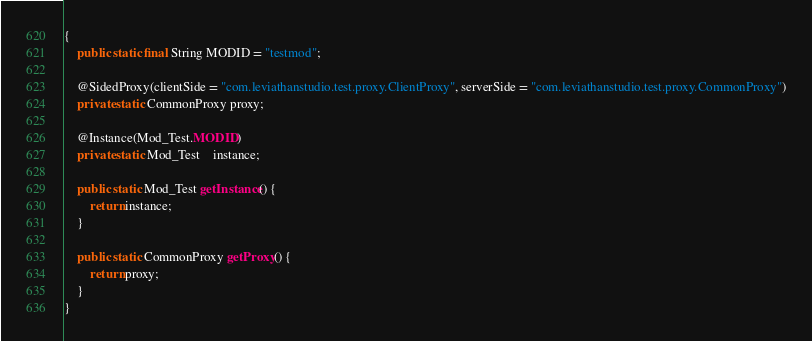<code> <loc_0><loc_0><loc_500><loc_500><_Java_>{
    public static final String MODID = "testmod";

    @SidedProxy(clientSide = "com.leviathanstudio.test.proxy.ClientProxy", serverSide = "com.leviathanstudio.test.proxy.CommonProxy")
    private static CommonProxy proxy;

    @Instance(Mod_Test.MODID)
    private static Mod_Test    instance;

    public static Mod_Test getInstance() {
        return instance;
    }

    public static CommonProxy getProxy() {
        return proxy;
    }
}</code> 